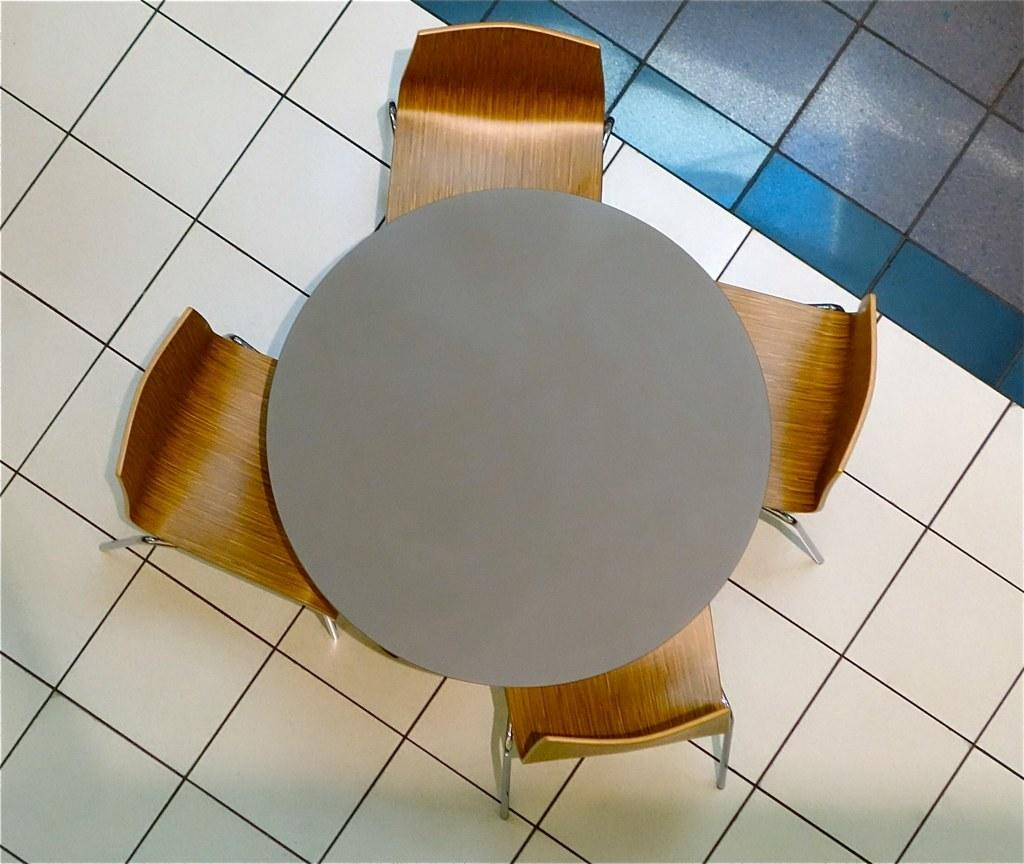What type of furniture is present in the image? There is a table in the image. How many chairs are positioned around the table? There are four chairs around the table. What type of flooring is visible in the image? The floor has tiles. Is there any steam coming from the table in the image? No, there is no steam present in the image. 